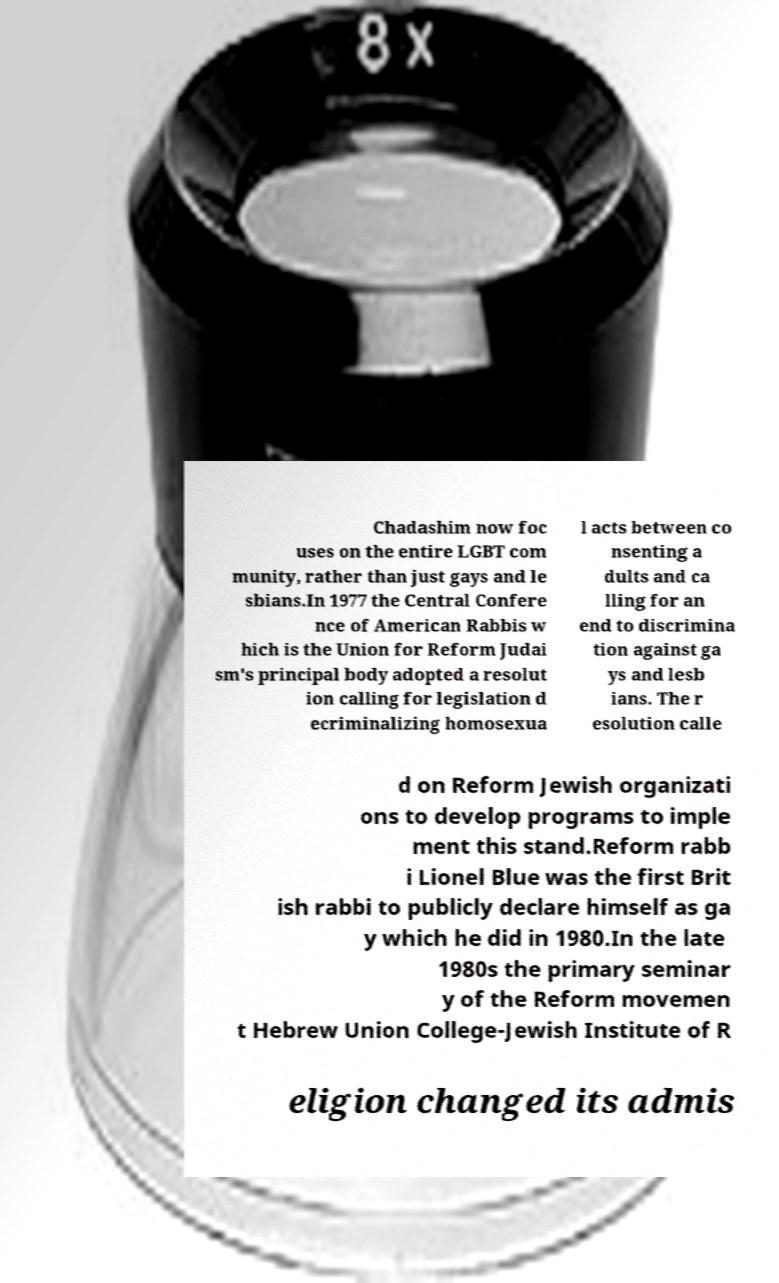There's text embedded in this image that I need extracted. Can you transcribe it verbatim? Chadashim now foc uses on the entire LGBT com munity, rather than just gays and le sbians.In 1977 the Central Confere nce of American Rabbis w hich is the Union for Reform Judai sm's principal body adopted a resolut ion calling for legislation d ecriminalizing homosexua l acts between co nsenting a dults and ca lling for an end to discrimina tion against ga ys and lesb ians. The r esolution calle d on Reform Jewish organizati ons to develop programs to imple ment this stand.Reform rabb i Lionel Blue was the first Brit ish rabbi to publicly declare himself as ga y which he did in 1980.In the late 1980s the primary seminar y of the Reform movemen t Hebrew Union College-Jewish Institute of R eligion changed its admis 